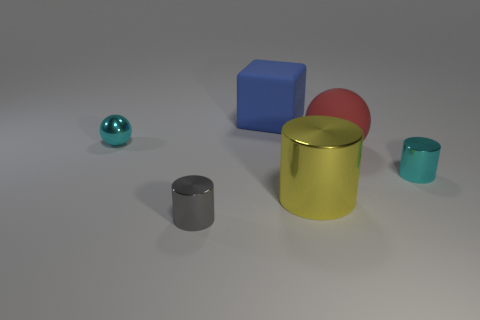Subtract all big metallic cylinders. How many cylinders are left? 2 Subtract 0 brown spheres. How many objects are left? 6 Subtract all blocks. How many objects are left? 5 Subtract 2 spheres. How many spheres are left? 0 Subtract all red spheres. Subtract all yellow cylinders. How many spheres are left? 1 Subtract all purple spheres. How many yellow cylinders are left? 1 Subtract all red cubes. Subtract all tiny cylinders. How many objects are left? 4 Add 1 yellow objects. How many yellow objects are left? 2 Add 2 big red objects. How many big red objects exist? 3 Add 2 blue rubber things. How many objects exist? 8 